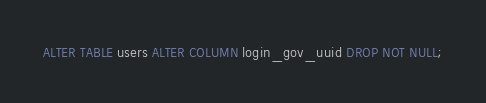<code> <loc_0><loc_0><loc_500><loc_500><_SQL_>ALTER TABLE users ALTER COLUMN login_gov_uuid DROP NOT NULL;</code> 